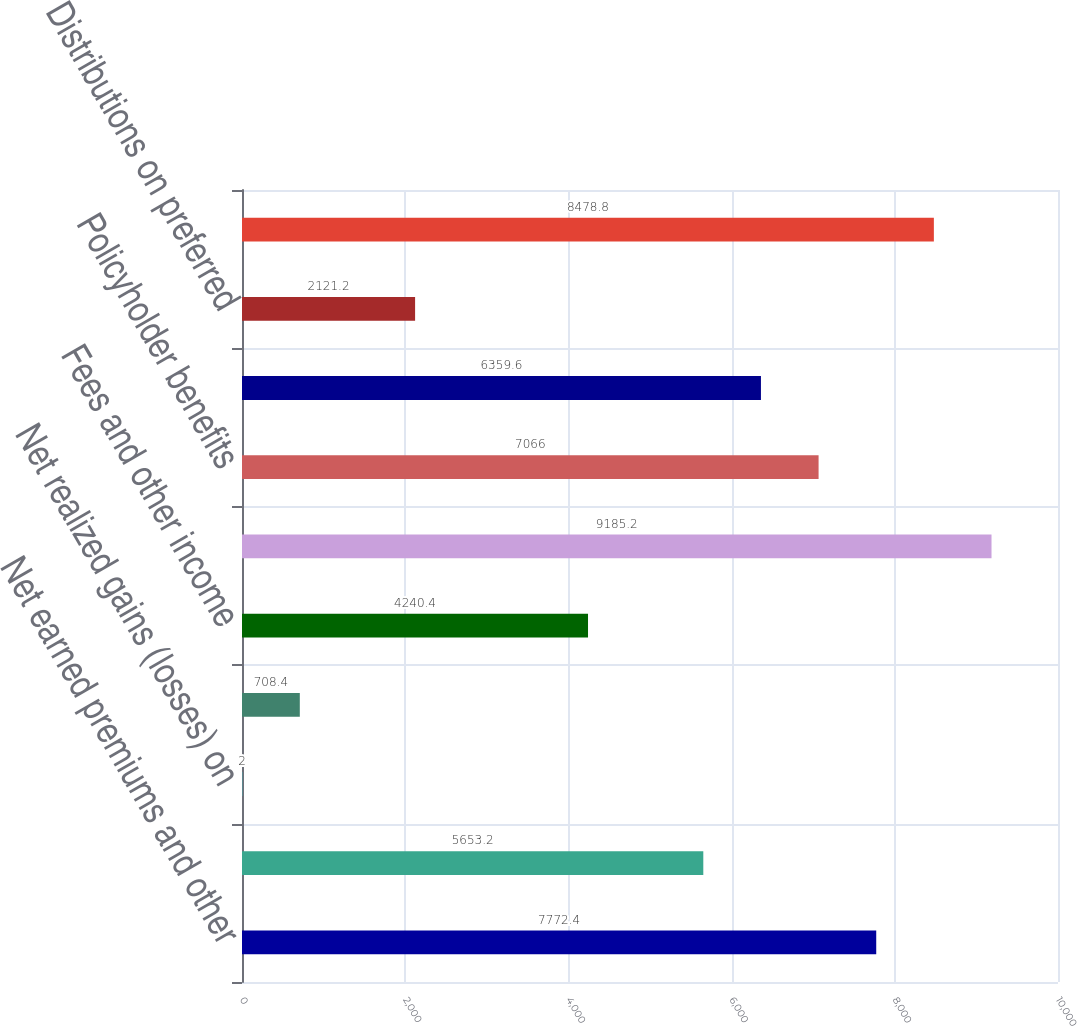Convert chart to OTSL. <chart><loc_0><loc_0><loc_500><loc_500><bar_chart><fcel>Net earned premiums and other<fcel>Net investment income<fcel>Net realized gains (losses) on<fcel>Amortization of deferred gains<fcel>Fees and other income<fcel>Total revenues<fcel>Policyholder benefits<fcel>Selling underwriting and<fcel>Distributions on preferred<fcel>Total benefits losses and<nl><fcel>7772.4<fcel>5653.2<fcel>2<fcel>708.4<fcel>4240.4<fcel>9185.2<fcel>7066<fcel>6359.6<fcel>2121.2<fcel>8478.8<nl></chart> 